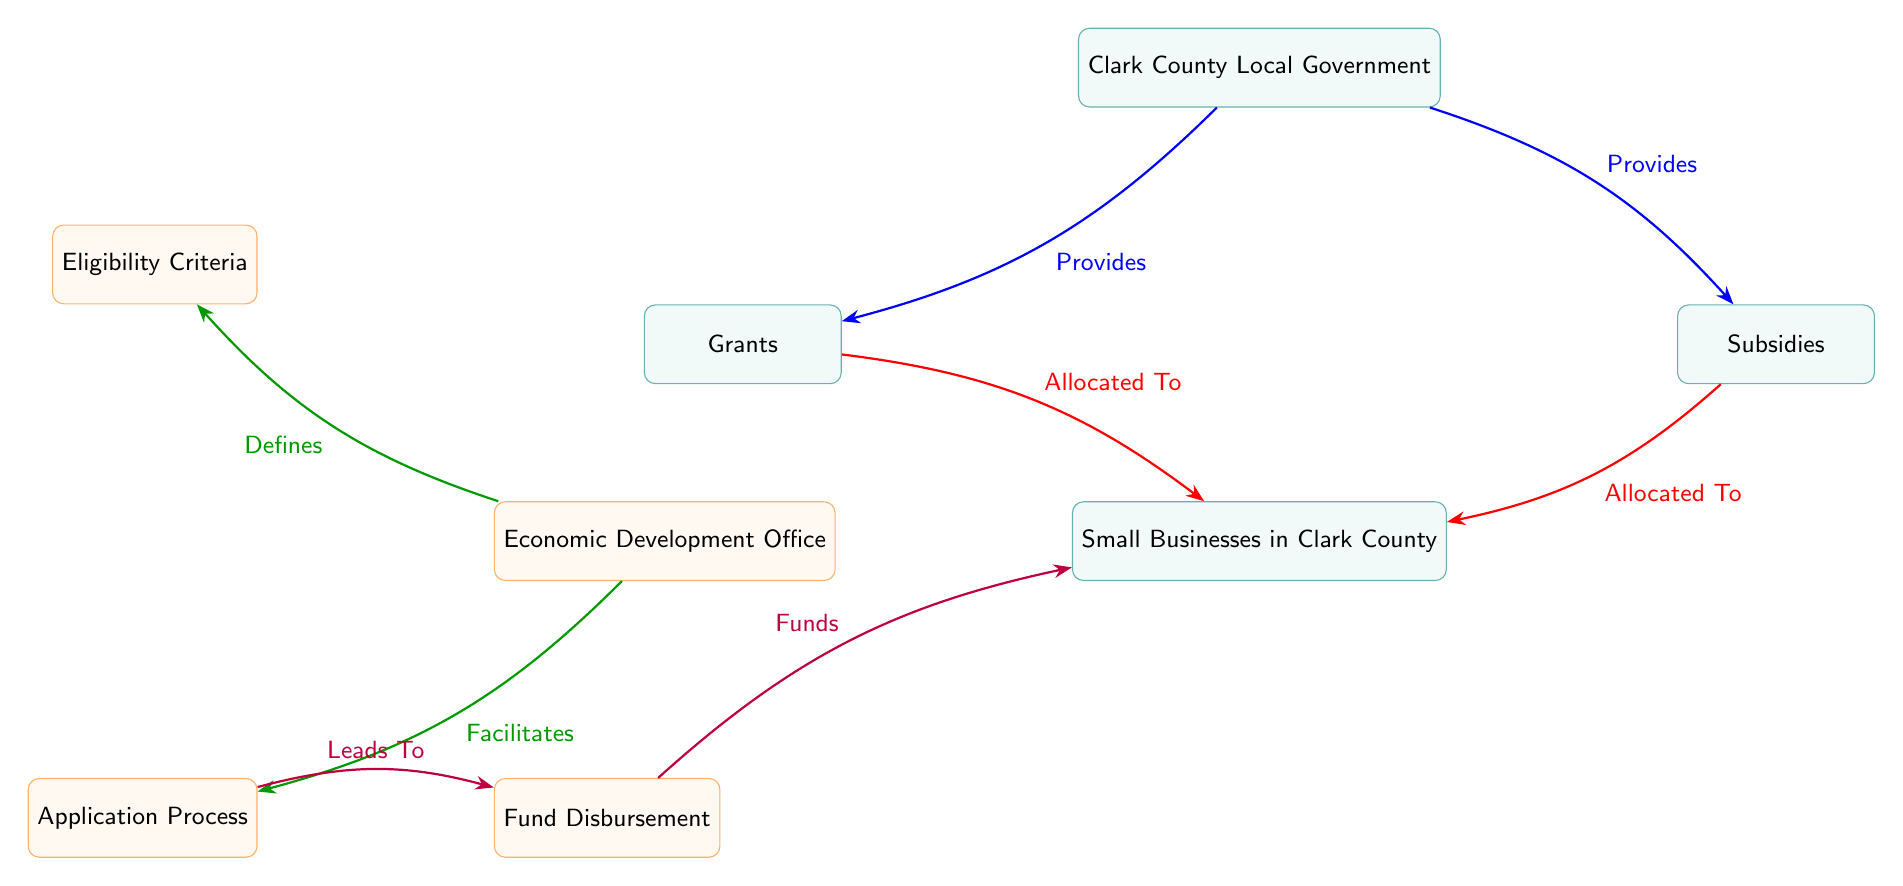What provides grants to small businesses? The diagram shows that the Clark County Local Government provides grants to small businesses. This relationship is signified by the directional arrow labeled "Provides" leading from the government to the grants node.
Answer: Clark County Local Government What type of support does the Clark County Local Government provide? According to the diagram, the Clark County Local Government provides both "Grants" and "Subsidies" as forms of support to small businesses, indicated by two arrows pointing from the government node to the grants and subsidies nodes.
Answer: Grants and Subsidies How many processes are related to the application process? The diagram indicates there are three processes connected to the application process: "Eligibility Criteria," "Application Process," and "Fund Disbursement." By counting the nodes connected to the application process, we establish there are three distinct processes.
Answer: Three What does the Economic Development Office facilitate? The diagram illustrates that the Economic Development Office facilitates the "Application Process," as shown by the arrow labeled "Facilitates" leading from the Economic Development Office node to the application process node.
Answer: Application Process Which entities are allocated funds from subsidies? The diagram specifies that subsidies are allocated to "Small Businesses in Clark County," demonstrated by the arrow labeled "Allocated To" pointing from the subsidies node to the businesses node.
Answer: Small Businesses in Clark County What defines eligibility criteria for the grants? The diagram reflects that the "Eligibility Criteria" is defined by the "Economic Development Office," indicated by the arrow labeled "Defines" from the Economic Development Office to the criteria node.
Answer: Economic Development Office How do funds reach small businesses? The diagram depicts that funds are distributed to small businesses from the "Fund Disbursement" process. This progression is demonstrated through the flow, starting from the application process, leading to fund disbursement, and finally connecting to small businesses.
Answer: Fund Disbursement What leads to fund disbursement? According to the diagram, the "Application Process" leads to "Fund Disbursement," as indicated by the directional arrow labeled "Leads To" connecting the two nodes.
Answer: Application Process 